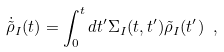Convert formula to latex. <formula><loc_0><loc_0><loc_500><loc_500>\dot { \tilde { \rho } } _ { I } ( t ) = \int _ { 0 } ^ { t } d t ^ { \prime } \Sigma _ { I } ( t , t ^ { \prime } ) \tilde { \rho } _ { I } ( t ^ { \prime } ) \ ,</formula> 